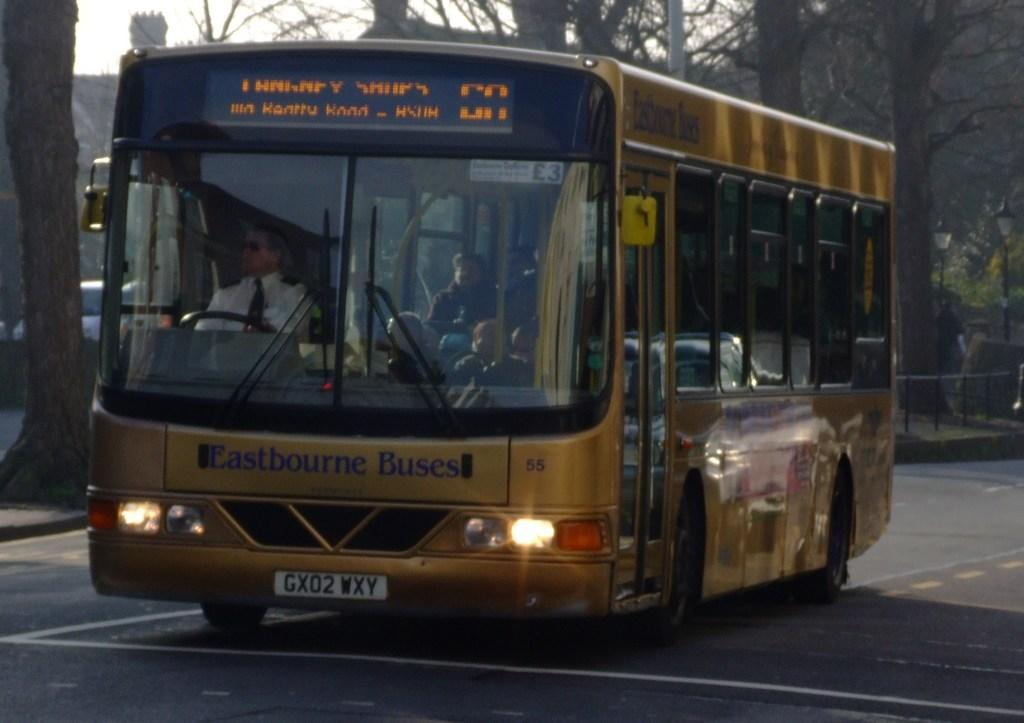What is the main subject of the image? The main subject of the image is a group of people inside a bus. How is the bus positioned in the image? The bus is placed on the ground. What can be seen in the background of the image? There is a group of trees, poles, at least one vehicle, and the sky visible in the background. What type of hope can be seen growing on the trees in the background? There is no mention of hope or any specific plant in the image; it only features a group of trees in the background. 